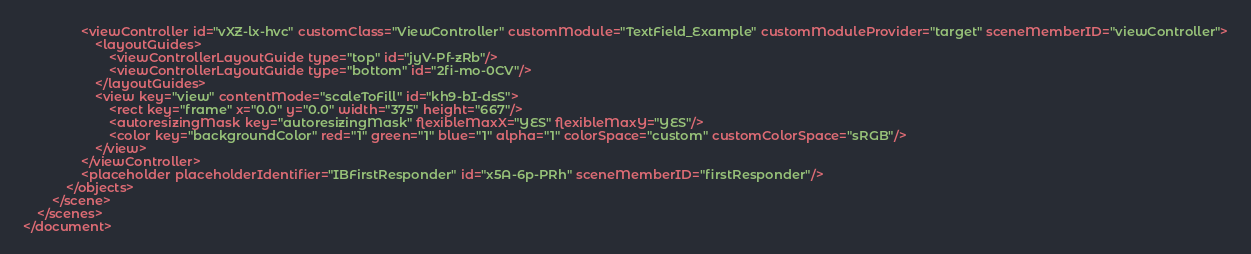Convert code to text. <code><loc_0><loc_0><loc_500><loc_500><_XML_>                <viewController id="vXZ-lx-hvc" customClass="ViewController" customModule="TextField_Example" customModuleProvider="target" sceneMemberID="viewController">
                    <layoutGuides>
                        <viewControllerLayoutGuide type="top" id="jyV-Pf-zRb"/>
                        <viewControllerLayoutGuide type="bottom" id="2fi-mo-0CV"/>
                    </layoutGuides>
                    <view key="view" contentMode="scaleToFill" id="kh9-bI-dsS">
                        <rect key="frame" x="0.0" y="0.0" width="375" height="667"/>
                        <autoresizingMask key="autoresizingMask" flexibleMaxX="YES" flexibleMaxY="YES"/>
                        <color key="backgroundColor" red="1" green="1" blue="1" alpha="1" colorSpace="custom" customColorSpace="sRGB"/>
                    </view>
                </viewController>
                <placeholder placeholderIdentifier="IBFirstResponder" id="x5A-6p-PRh" sceneMemberID="firstResponder"/>
            </objects>
        </scene>
    </scenes>
</document>
</code> 